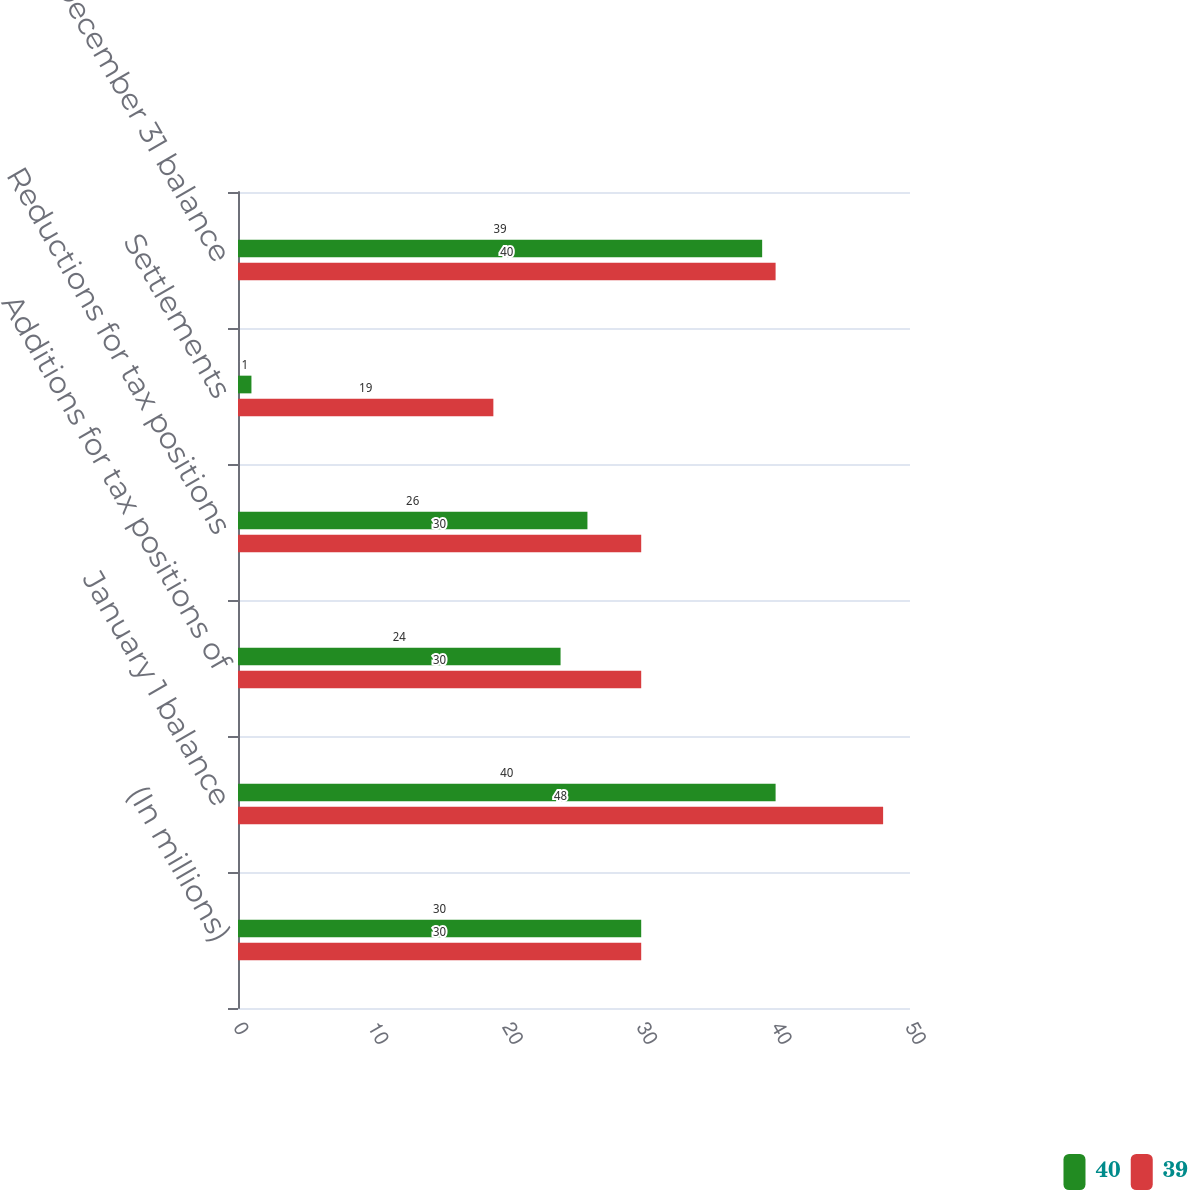Convert chart. <chart><loc_0><loc_0><loc_500><loc_500><stacked_bar_chart><ecel><fcel>(In millions)<fcel>January 1 balance<fcel>Additions for tax positions of<fcel>Reductions for tax positions<fcel>Settlements<fcel>December 31 balance<nl><fcel>40<fcel>30<fcel>40<fcel>24<fcel>26<fcel>1<fcel>39<nl><fcel>39<fcel>30<fcel>48<fcel>30<fcel>30<fcel>19<fcel>40<nl></chart> 